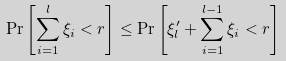<formula> <loc_0><loc_0><loc_500><loc_500>\Pr \left [ \sum _ { i = 1 } ^ { l } \xi _ { i } < r \right ] \leq \Pr \left [ \xi _ { l } ^ { \prime } + \sum _ { i = 1 } ^ { l - 1 } \xi _ { i } < r \right ]</formula> 